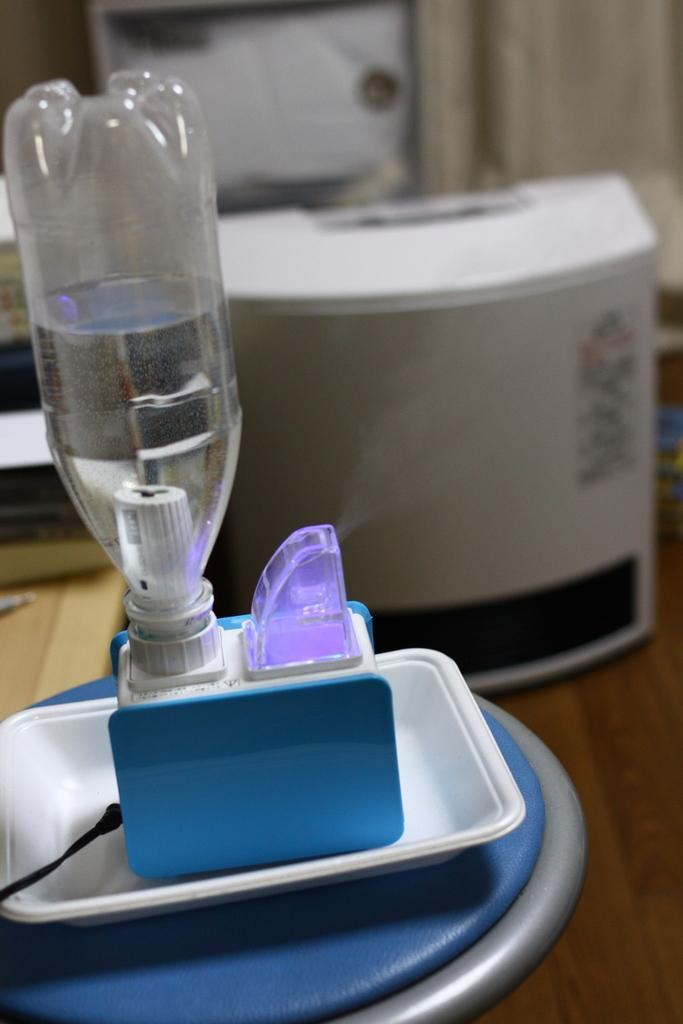What object can be seen in the image with a stopper? There is a bottle in the image with a stopper. What is the color of the box in the background of the image? The box in the background of the image is white. Where is the white box located? The white box is kept on a table. What type of toys can be seen in the image? There are no toys present in the image. What kind of lace is used to decorate the bottle in the image? The bottle in the image does not have any lace decoration. 